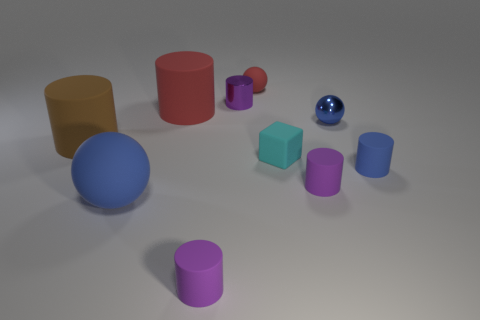How many purple cylinders must be subtracted to get 1 purple cylinders? 2 Subtract all red cylinders. How many blue balls are left? 2 Subtract all big cylinders. How many cylinders are left? 4 Subtract 2 cylinders. How many cylinders are left? 4 Subtract all brown cylinders. How many cylinders are left? 5 Subtract all blocks. How many objects are left? 9 Subtract all small red matte balls. Subtract all tiny purple rubber objects. How many objects are left? 7 Add 2 cylinders. How many cylinders are left? 8 Add 1 tiny red balls. How many tiny red balls exist? 2 Subtract 0 green spheres. How many objects are left? 10 